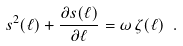Convert formula to latex. <formula><loc_0><loc_0><loc_500><loc_500>s ^ { 2 } ( \ell ) + \frac { \partial s ( \ell ) } { \partial \ell } = \omega \, \zeta ( \ell ) \ .</formula> 